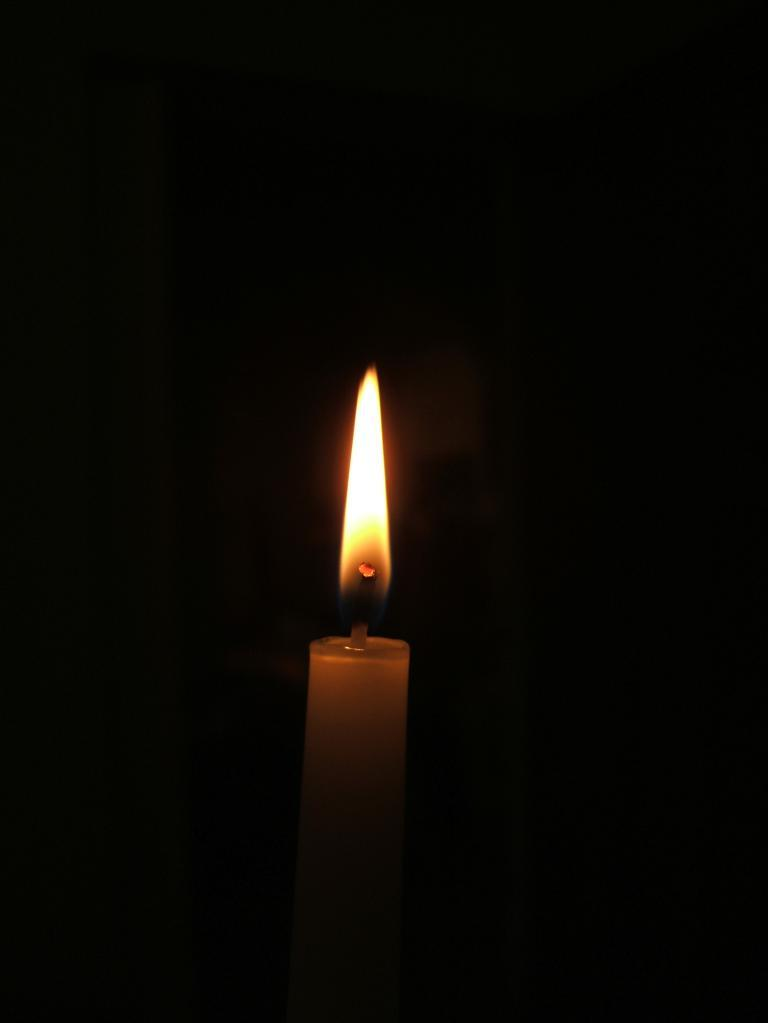What object can be seen in the image? There is a wax candle in the image. What is happening to the wax candle? The wax candle has a flame. How would you describe the overall lighting in the image? The background of the image appears dark. How many words can be seen on the arch in the image? There is no arch or words present in the image; it only features a wax candle with a flame. 